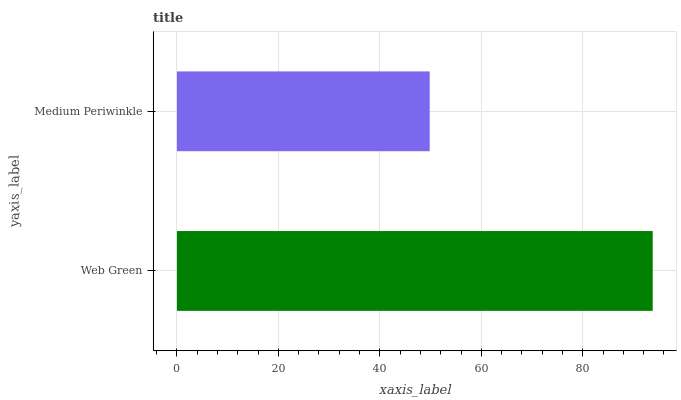Is Medium Periwinkle the minimum?
Answer yes or no. Yes. Is Web Green the maximum?
Answer yes or no. Yes. Is Medium Periwinkle the maximum?
Answer yes or no. No. Is Web Green greater than Medium Periwinkle?
Answer yes or no. Yes. Is Medium Periwinkle less than Web Green?
Answer yes or no. Yes. Is Medium Periwinkle greater than Web Green?
Answer yes or no. No. Is Web Green less than Medium Periwinkle?
Answer yes or no. No. Is Web Green the high median?
Answer yes or no. Yes. Is Medium Periwinkle the low median?
Answer yes or no. Yes. Is Medium Periwinkle the high median?
Answer yes or no. No. Is Web Green the low median?
Answer yes or no. No. 